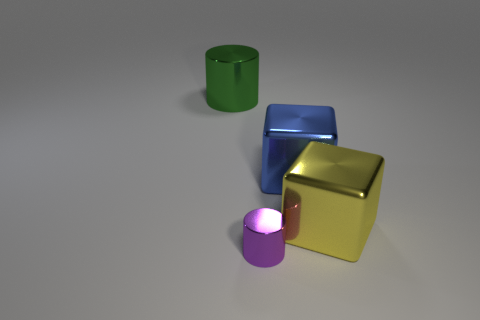Add 3 large objects. How many objects exist? 7 Subtract all green cylinders. How many cylinders are left? 1 Subtract all purple cubes. How many green cylinders are left? 1 Subtract all small purple matte cylinders. Subtract all purple metal cylinders. How many objects are left? 3 Add 2 purple metal objects. How many purple metal objects are left? 3 Add 4 big brown matte spheres. How many big brown matte spheres exist? 4 Subtract 1 yellow cubes. How many objects are left? 3 Subtract all purple cylinders. Subtract all red balls. How many cylinders are left? 1 